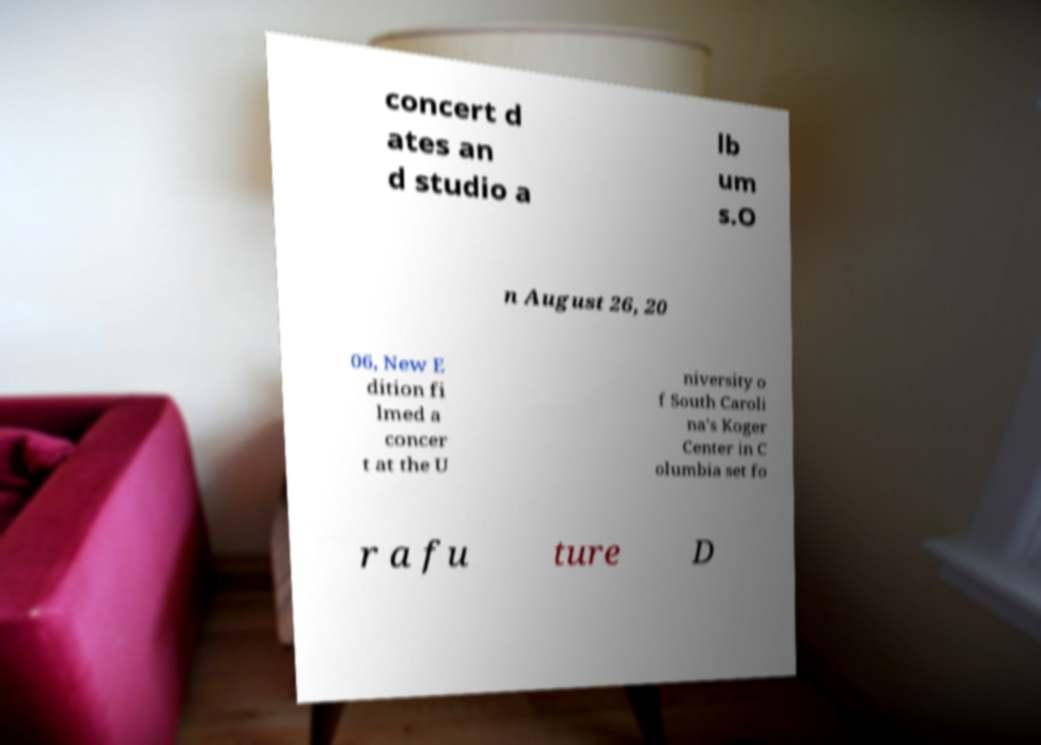What messages or text are displayed in this image? I need them in a readable, typed format. concert d ates an d studio a lb um s.O n August 26, 20 06, New E dition fi lmed a concer t at the U niversity o f South Caroli na's Koger Center in C olumbia set fo r a fu ture D 